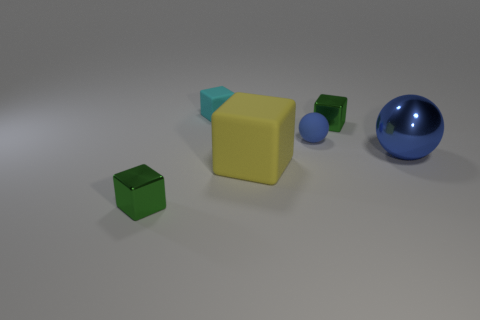Can you tell me the colors of the objects in this image? Certainly! In the image, there are objects with the following colors: a large blue sphere, a yellow cube, a green small cube, a smaller blue sphere, and a cyan smaller cube. 